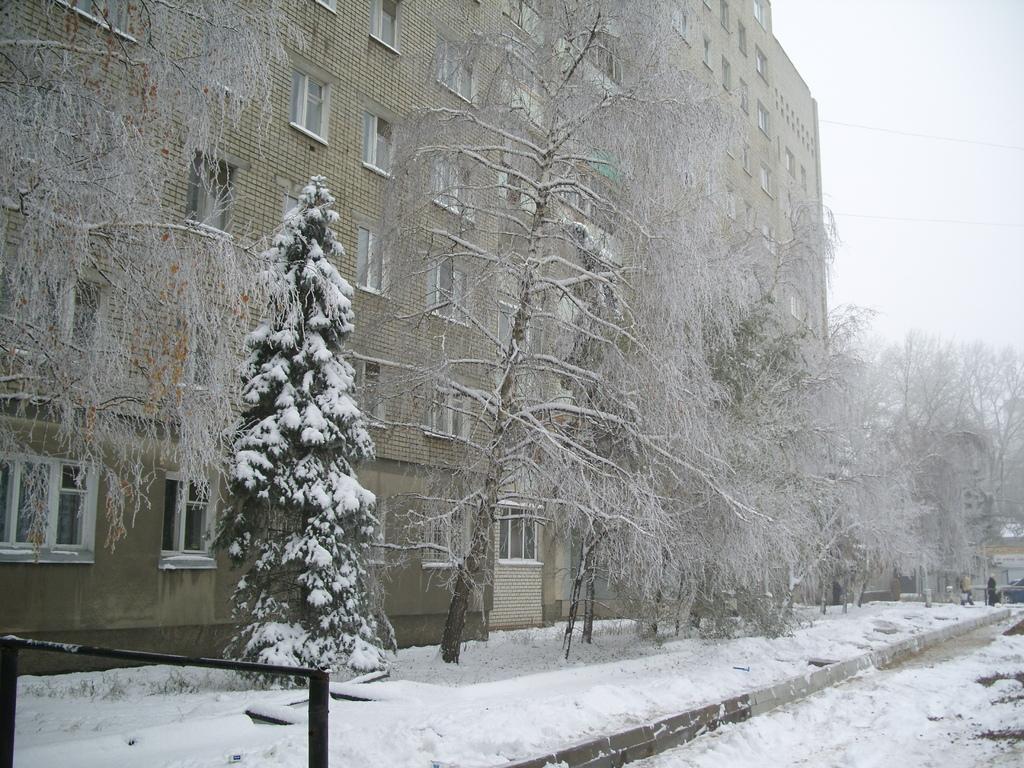Describe this image in one or two sentences. In the image we can see the building and these are the windows of the building. We can even see there are trees, snow and the sky. 